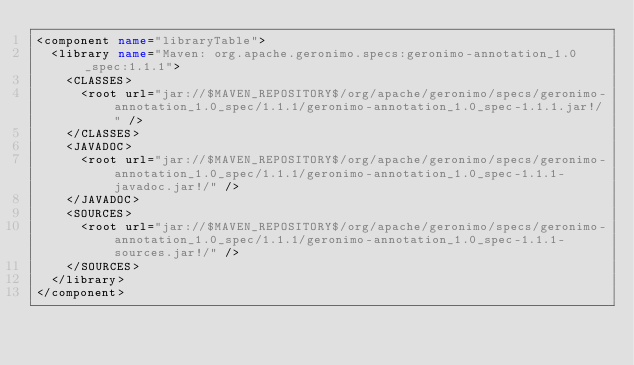<code> <loc_0><loc_0><loc_500><loc_500><_XML_><component name="libraryTable">
  <library name="Maven: org.apache.geronimo.specs:geronimo-annotation_1.0_spec:1.1.1">
    <CLASSES>
      <root url="jar://$MAVEN_REPOSITORY$/org/apache/geronimo/specs/geronimo-annotation_1.0_spec/1.1.1/geronimo-annotation_1.0_spec-1.1.1.jar!/" />
    </CLASSES>
    <JAVADOC>
      <root url="jar://$MAVEN_REPOSITORY$/org/apache/geronimo/specs/geronimo-annotation_1.0_spec/1.1.1/geronimo-annotation_1.0_spec-1.1.1-javadoc.jar!/" />
    </JAVADOC>
    <SOURCES>
      <root url="jar://$MAVEN_REPOSITORY$/org/apache/geronimo/specs/geronimo-annotation_1.0_spec/1.1.1/geronimo-annotation_1.0_spec-1.1.1-sources.jar!/" />
    </SOURCES>
  </library>
</component></code> 